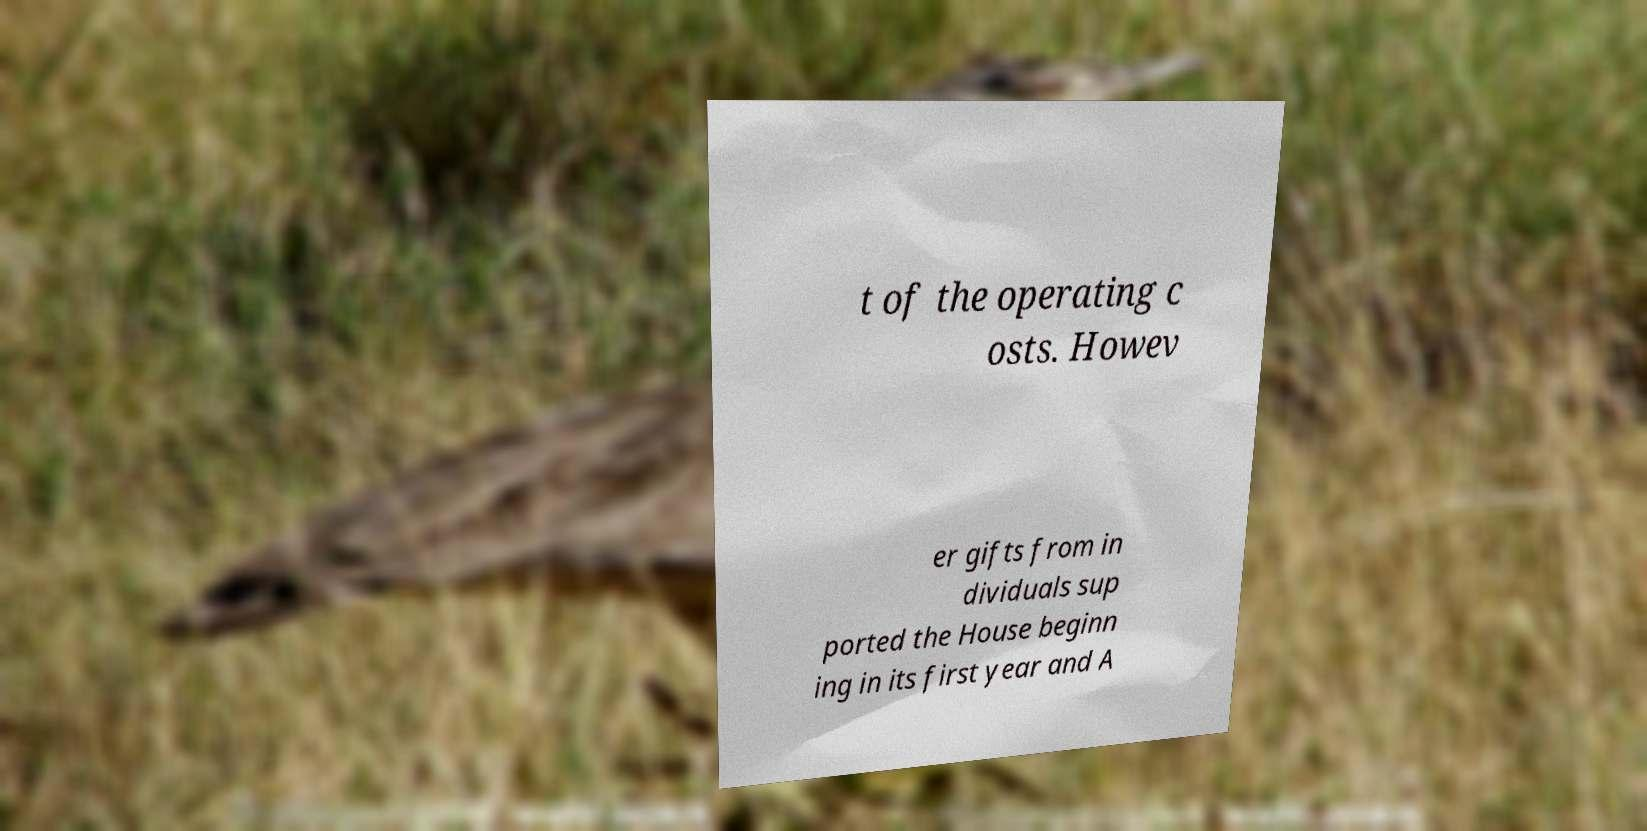I need the written content from this picture converted into text. Can you do that? t of the operating c osts. Howev er gifts from in dividuals sup ported the House beginn ing in its first year and A 